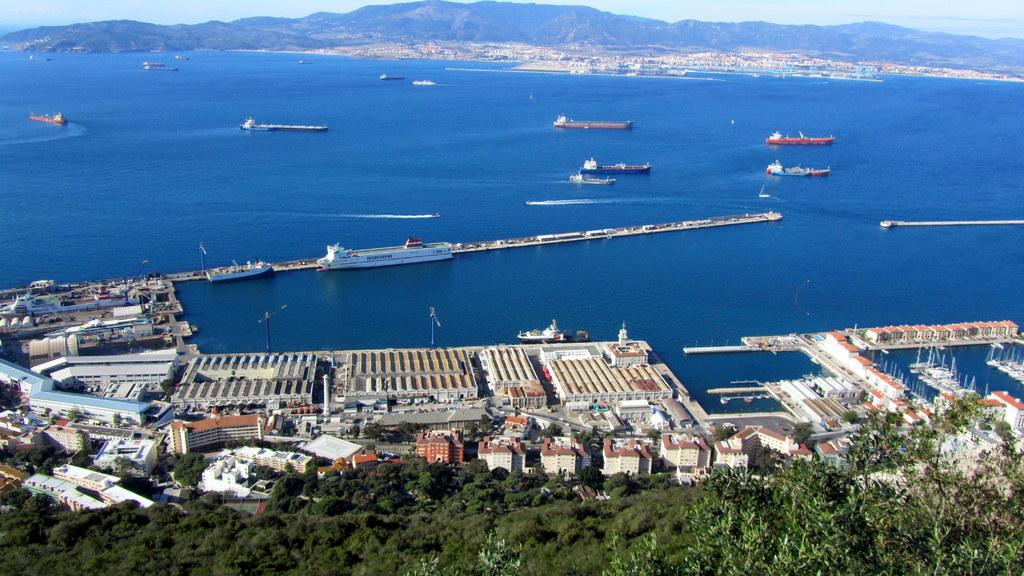What type of structures can be seen in the image? There are buildings in the image. What natural elements are present in the image? There are trees and a river in the image. What are the boats used for in the image? The boats are on a river, suggesting they are used for transportation or leisure activities. What can be seen in the distance in the image? There are mountains in the background of the image. What is visible above the buildings and trees in the image? The sky is visible in the background of the image. Can you see any dinosaurs roaming around near the river in the image? No, there are no dinosaurs present in the image. What type of comb is being used to groom the trees in the image? There is no comb visible in the image, and trees do not require grooming. 